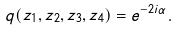Convert formula to latex. <formula><loc_0><loc_0><loc_500><loc_500>q ( z _ { 1 } , z _ { 2 } , z _ { 3 } , z _ { 4 } ) = e ^ { - 2 i \alpha } .</formula> 